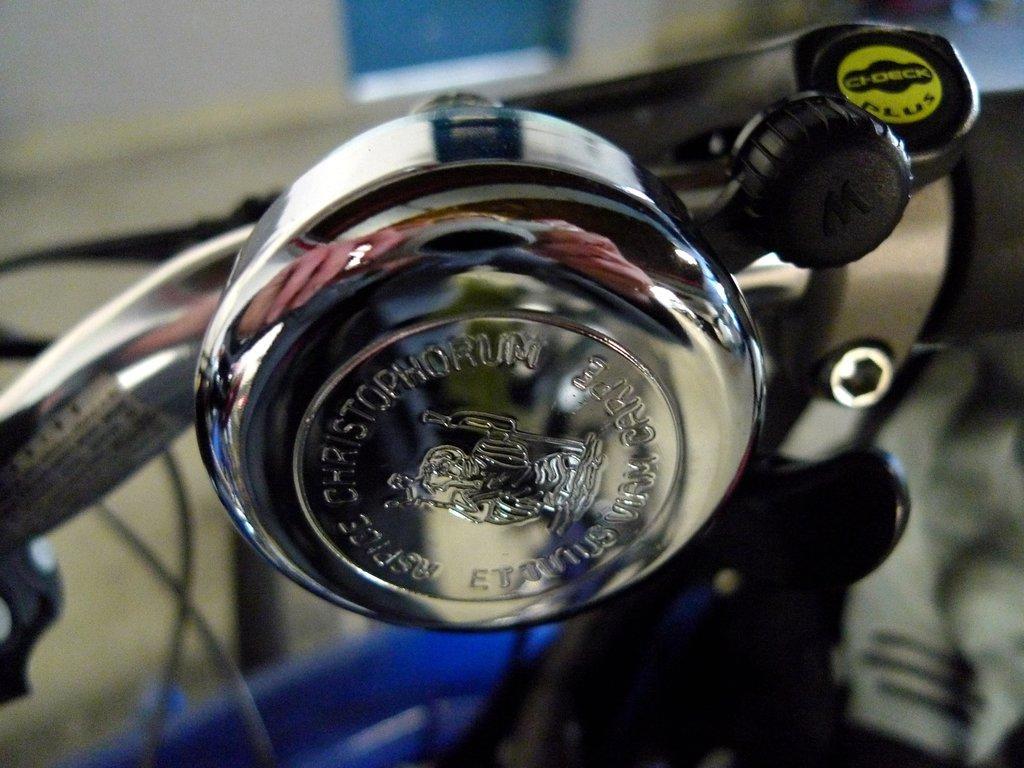Describe this image in one or two sentences. In this image I can see a metal object which is attached to a bicycle. The background is blurred. 